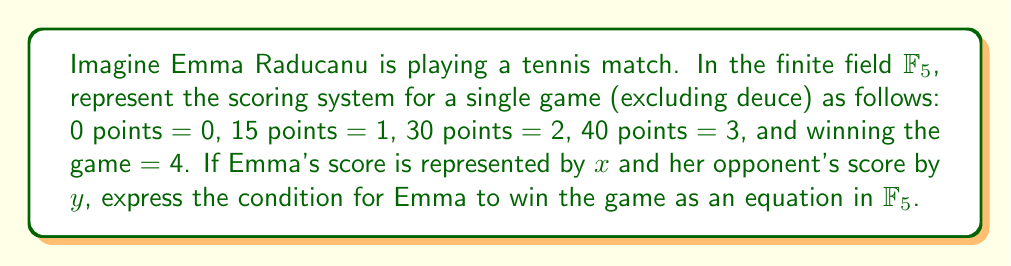Solve this math problem. Let's approach this step-by-step:

1) In $\mathbb{F}_5$, we have the following representation:
   0 points → 0
   15 points → 1
   30 points → 2
   40 points → 3
   Win → 4

2) For Emma to win, she needs to reach 4 while her opponent is at 0, 1, or 2.

3) We can express this as: $x = 4$ AND $y < 3$

4) In field theory, we can use the characteristic of $\mathbb{F}_5$ to our advantage. In $\mathbb{F}_5$, $4 \equiv -1 \pmod{5}$

5) We can rewrite the condition as: $x \equiv -1 \pmod{5}$ AND $y \in \{0, 1, 2\}$

6) To combine these into a single equation, we can use the fact that in $\mathbb{F}_5$:
   $(y-0)(y-1)(y-2) \equiv 0 \pmod{5}$ if and only if $y \in \{0, 1, 2\}$

7) Therefore, the condition for Emma to win can be expressed as:
   $$(x+1)((y-0)(y-1)(y-2)) \equiv 0 \pmod{5}$$

8) Expanding this:
   $$(x+1)(y^3-3y^2+2y) \equiv 0 \pmod{5}$$

This equation in $\mathbb{F}_5$ represents the condition for Emma Raducanu to win a single game in tennis.
Answer: $(x+1)(y^3-3y^2+2y) \equiv 0 \pmod{5}$ 